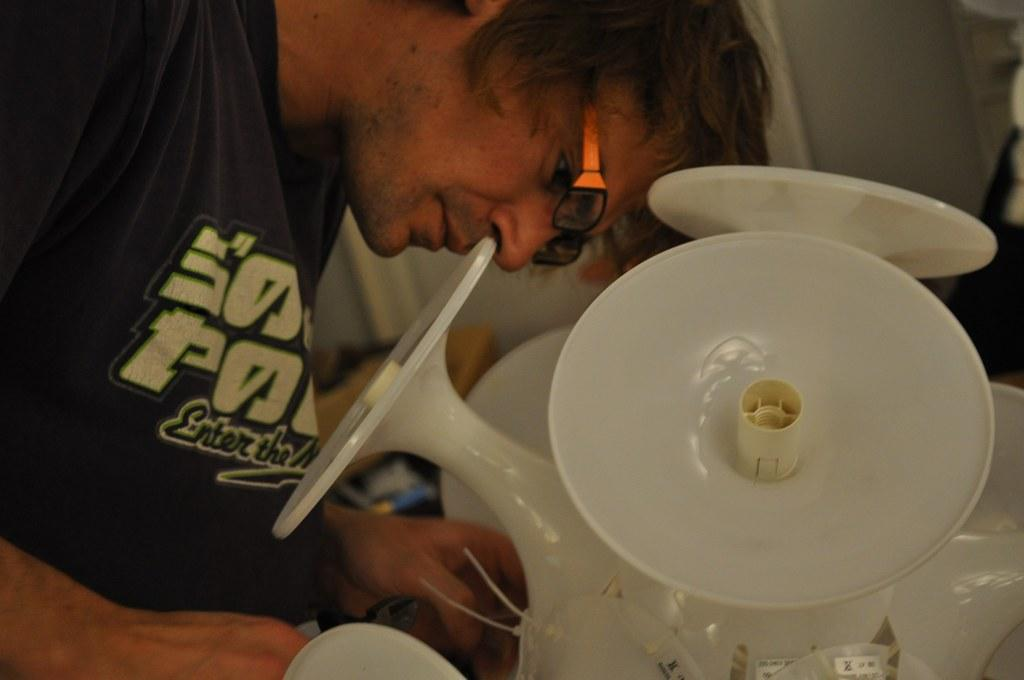Who is present in the image? There is a man in the image. What is the man wearing? The man is wearing spectacles. What can be seen in the image besides the man? There are objects in the image. What is visible in the background of the image? There is a wall in the background of the image. What type of kite is the man flying in the image? There is no kite present in the image; the man is not flying a kite. How many family members are visible in the image? There is no reference to family members in the image; only the man is present. 